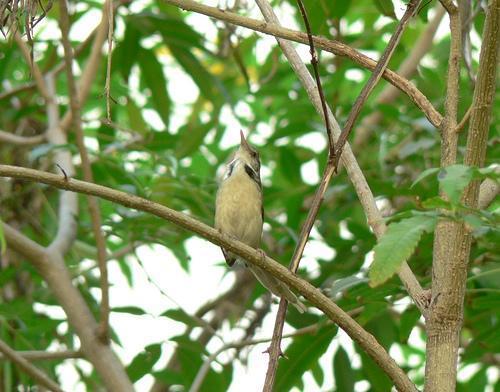How many pieces of cheese pizza are there?
Give a very brief answer. 0. 